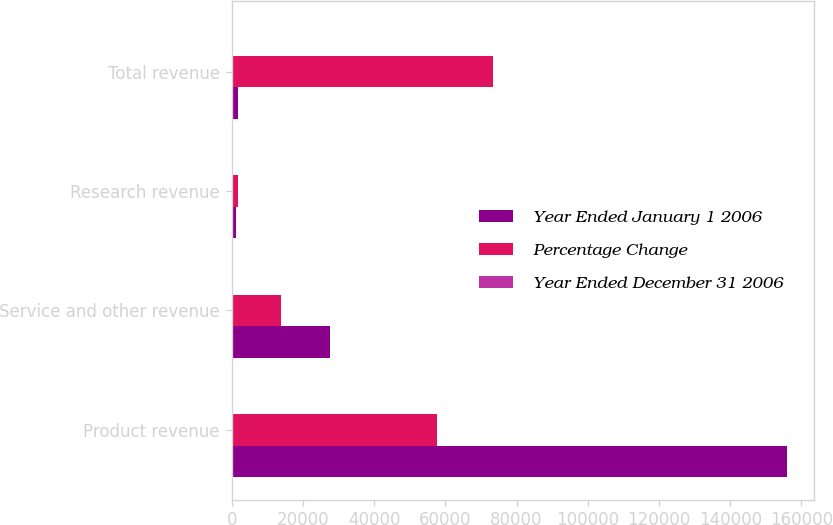Convert chart to OTSL. <chart><loc_0><loc_0><loc_500><loc_500><stacked_bar_chart><ecel><fcel>Product revenue<fcel>Service and other revenue<fcel>Research revenue<fcel>Total revenue<nl><fcel>Year Ended January 1 2006<fcel>155811<fcel>27486<fcel>1289<fcel>1814<nl><fcel>Percentage Change<fcel>57752<fcel>13935<fcel>1814<fcel>73501<nl><fcel>Year Ended December 31 2006<fcel>170<fcel>97<fcel>29<fcel>151<nl></chart> 